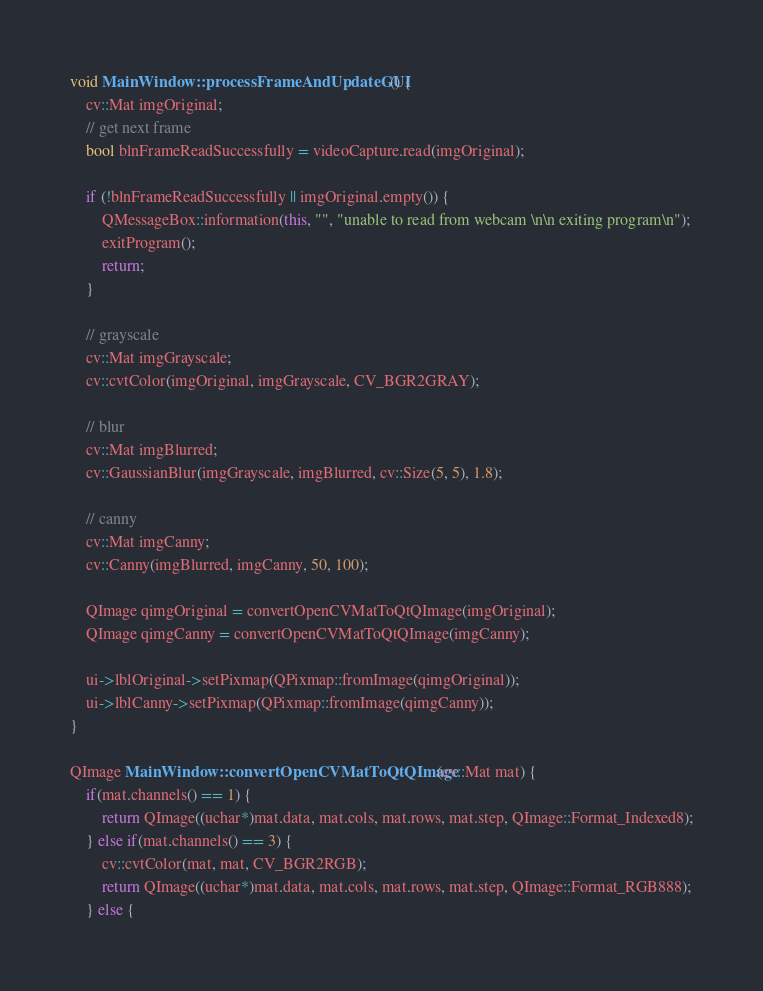Convert code to text. <code><loc_0><loc_0><loc_500><loc_500><_C++_>
void MainWindow::processFrameAndUpdateGUI() {
    cv::Mat imgOriginal;
    // get next frame
    bool blnFrameReadSuccessfully = videoCapture.read(imgOriginal);

    if (!blnFrameReadSuccessfully || imgOriginal.empty()) {
        QMessageBox::information(this, "", "unable to read from webcam \n\n exiting program\n");
        exitProgram();
        return;
    }

    // grayscale
    cv::Mat imgGrayscale;
    cv::cvtColor(imgOriginal, imgGrayscale, CV_BGR2GRAY);

    // blur
    cv::Mat imgBlurred;
    cv::GaussianBlur(imgGrayscale, imgBlurred, cv::Size(5, 5), 1.8);

    // canny
    cv::Mat imgCanny;
    cv::Canny(imgBlurred, imgCanny, 50, 100);

    QImage qimgOriginal = convertOpenCVMatToQtQImage(imgOriginal);
    QImage qimgCanny = convertOpenCVMatToQtQImage(imgCanny);

    ui->lblOriginal->setPixmap(QPixmap::fromImage(qimgOriginal));
    ui->lblCanny->setPixmap(QPixmap::fromImage(qimgCanny));
}

QImage MainWindow::convertOpenCVMatToQtQImage(cv::Mat mat) {
    if(mat.channels() == 1) {
        return QImage((uchar*)mat.data, mat.cols, mat.rows, mat.step, QImage::Format_Indexed8);
    } else if(mat.channels() == 3) {
        cv::cvtColor(mat, mat, CV_BGR2RGB);
        return QImage((uchar*)mat.data, mat.cols, mat.rows, mat.step, QImage::Format_RGB888);
    } else {</code> 